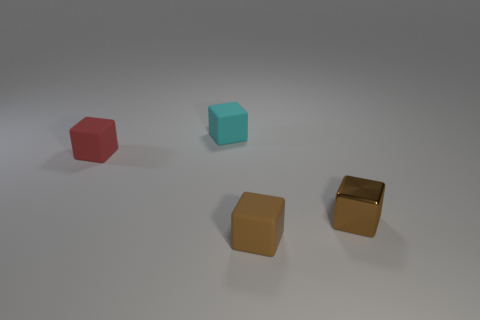Add 3 tiny red matte cylinders. How many objects exist? 7 Subtract 0 purple cylinders. How many objects are left? 4 Subtract all matte cubes. Subtract all purple cylinders. How many objects are left? 1 Add 1 brown shiny blocks. How many brown shiny blocks are left? 2 Add 2 red things. How many red things exist? 3 